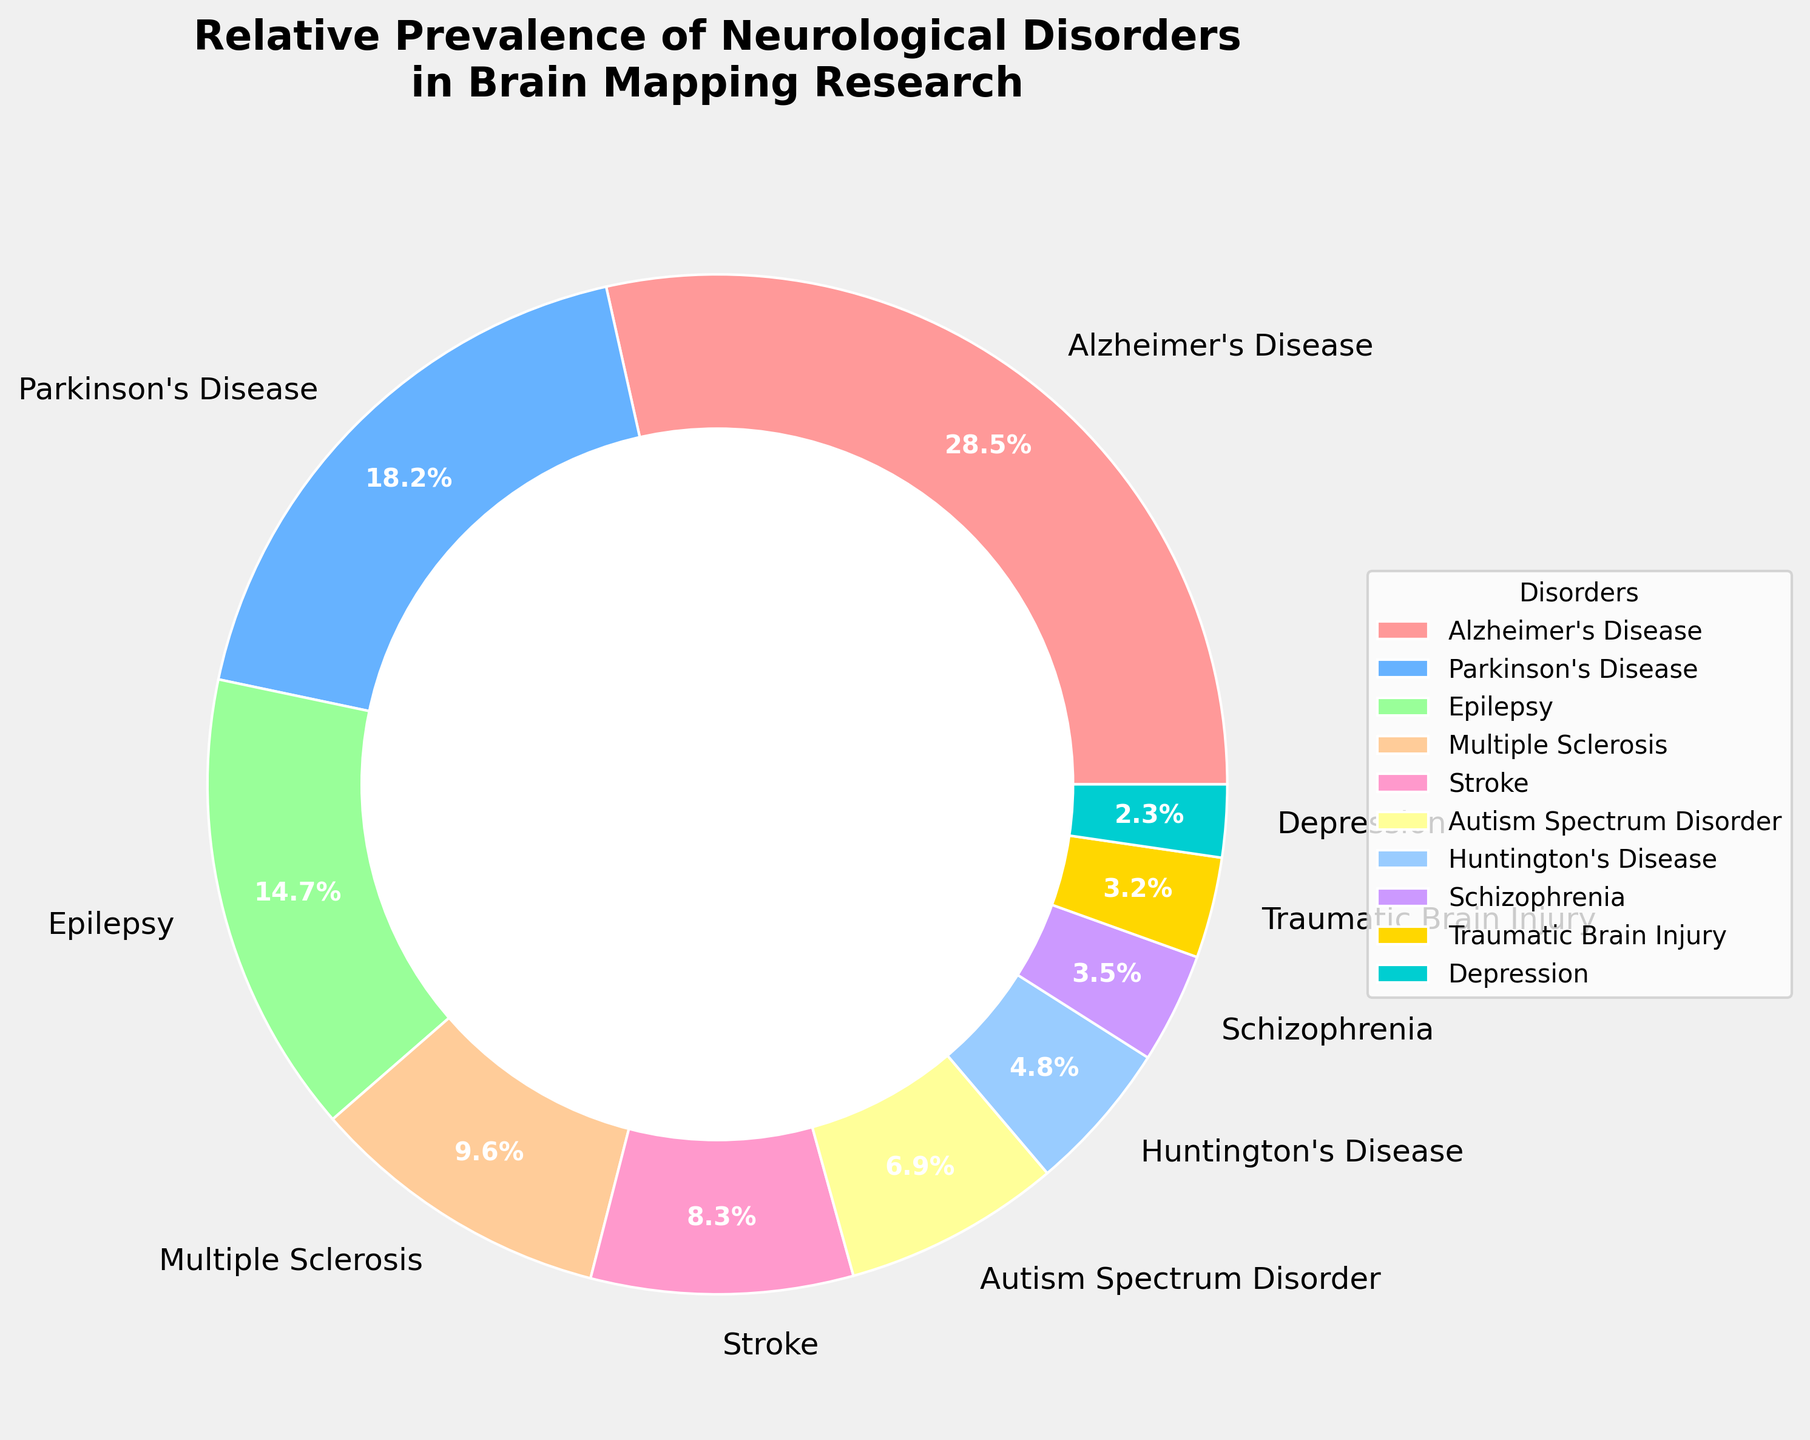What percentage of research focuses on Alzheimer's Disease? From the pie chart, observe the labeled slice for Alzheimer's Disease. It is labeled 28.5%.
Answer: 28.5% Which disorder has the lowest prevalence and what is it? Identify the slice with the smallest percentage and read its label, which is Depression at 2.3%.
Answer: Depression, 2.3% Is the percentage of research on Parkinson's Disease greater than on Epilepsy? Compare the two segments labeled Parkinson's Disease (18.2%) and Epilepsy (14.7%). 18.2% is greater than 14.7%.
Answer: Yes What is the combined percentage of research on Stroke and Autism Spectrum Disorder? Add the percentages of Stroke (8.3%) and Autism Spectrum Disorder (6.9%). 8.3% + 6.9% = 15.2%.
Answer: 15.2% Which three disorders have the highest percentages of brain mapping research focus, and what are their percentages? Find the three largest slices: Alzheimer's Disease (28.5%), Parkinson's Disease (18.2%), and Epilepsy (14.7%).
Answer: Alzheimer's Disease (28.5%), Parkinson's Disease (18.2%), Epilepsy (14.7%) What is the difference in research focus percentages between Multiple Sclerosis and Schizophrenia? Subtract the percentage of Schizophrenia (3.5%) from Multiple Sclerosis (9.6%). 9.6% - 3.5% = 6.1%.
Answer: 6.1% How does the research focus on Traumatic Brain Injury compare to Huntington's Disease? Compare the two segments labeled Traumatic Brain Injury (3.2%) and Huntington's Disease (4.8%). 3.2% is less than 4.8%.
Answer: Less Which disorder has a prevalence closest to 10% in brain mapping research? Check the segment closest to 10%. Multiple Sclerosis is at 9.6%, which is closest to 10%.
Answer: Multiple Sclerosis What is the total percentage of research on Alzheimer’s Disease, Parkinson’s Disease, and Epilepsy combined? Add Alzheimer's Disease (28.5%), Parkinson's Disease (18.2%), and Epilepsy (14.7%). 28.5% + 18.2% + 14.7% = 61.4%.
Answer: 61.4% What color represents Autism Spectrum Disorder on the chart? Identify the section labeled Autism Spectrum Disorder and note its color, which is yellow.
Answer: Yellow 